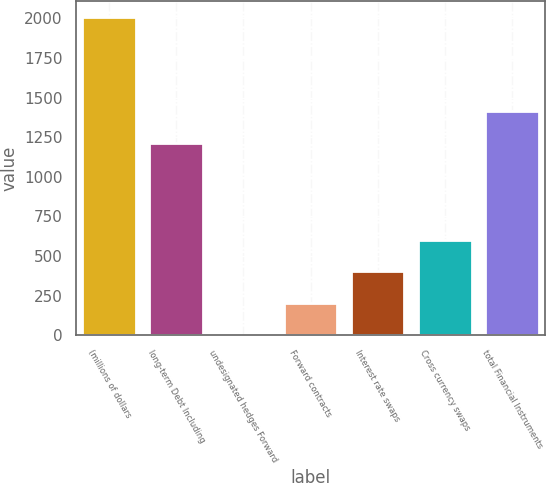<chart> <loc_0><loc_0><loc_500><loc_500><bar_chart><fcel>(millions of dollars<fcel>long-term Debt Including<fcel>undesignated hedges Forward<fcel>Forward contracts<fcel>Interest rate swaps<fcel>Cross currency swaps<fcel>total Financial Instruments<nl><fcel>2007<fcel>1212.1<fcel>0.9<fcel>201.51<fcel>402.12<fcel>602.73<fcel>1412.71<nl></chart> 